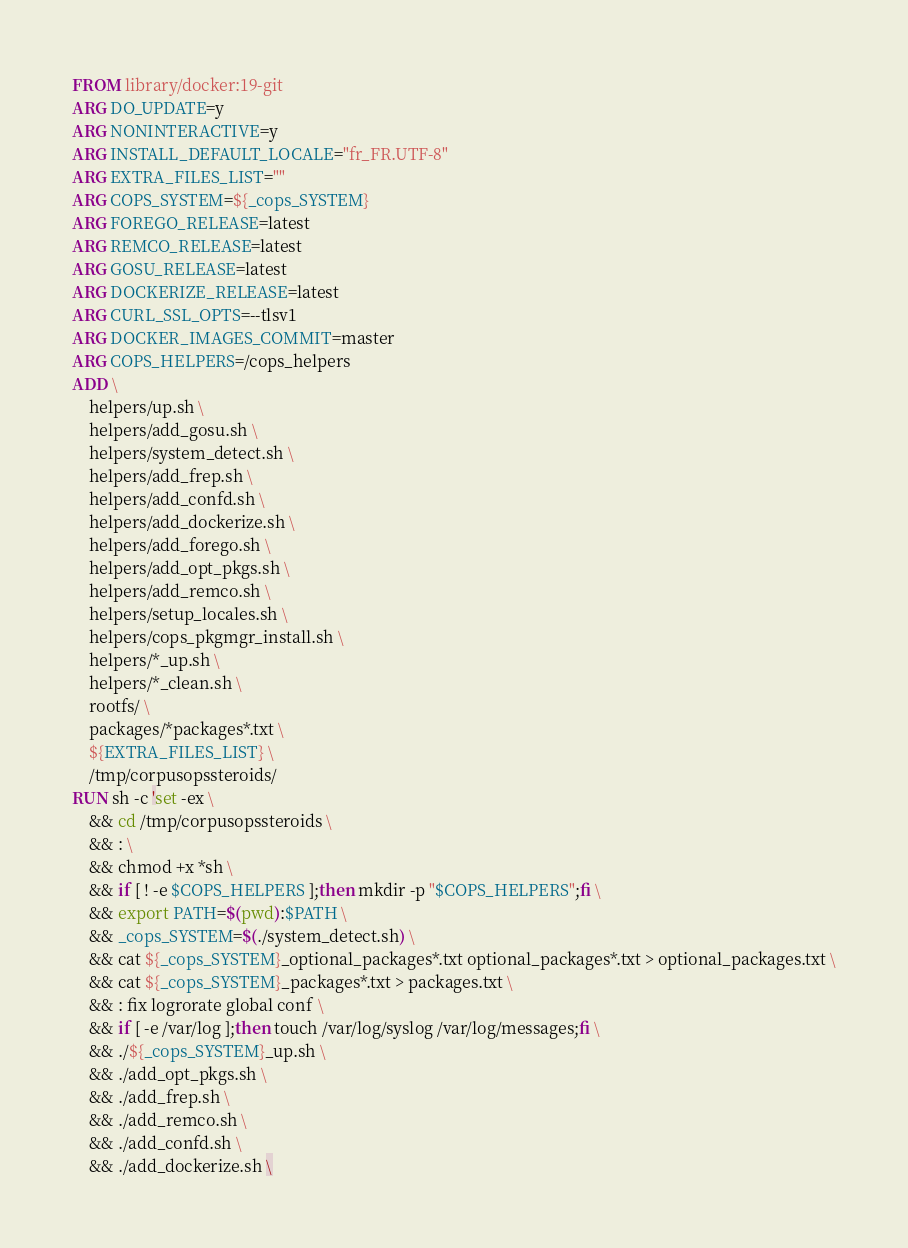<code> <loc_0><loc_0><loc_500><loc_500><_Dockerfile_>FROM library/docker:19-git
ARG DO_UPDATE=y
ARG NONINTERACTIVE=y
ARG INSTALL_DEFAULT_LOCALE="fr_FR.UTF-8"
ARG EXTRA_FILES_LIST=""
ARG COPS_SYSTEM=${_cops_SYSTEM}
ARG FOREGO_RELEASE=latest
ARG REMCO_RELEASE=latest
ARG GOSU_RELEASE=latest
ARG DOCKERIZE_RELEASE=latest
ARG CURL_SSL_OPTS=--tlsv1
ARG DOCKER_IMAGES_COMMIT=master
ARG COPS_HELPERS=/cops_helpers
ADD \
    helpers/up.sh \
    helpers/add_gosu.sh \
    helpers/system_detect.sh \
    helpers/add_frep.sh \
    helpers/add_confd.sh \
    helpers/add_dockerize.sh \
    helpers/add_forego.sh \
    helpers/add_opt_pkgs.sh \
    helpers/add_remco.sh \
    helpers/setup_locales.sh \
    helpers/cops_pkgmgr_install.sh \
    helpers/*_up.sh \
    helpers/*_clean.sh \
    rootfs/ \
    packages/*packages*.txt \
    ${EXTRA_FILES_LIST} \
    /tmp/corpusopssteroids/
RUN sh -c 'set -ex \
    && cd /tmp/corpusopssteroids \
    && : \
    && chmod +x *sh \
    && if [ ! -e $COPS_HELPERS ];then mkdir -p "$COPS_HELPERS";fi \
    && export PATH=$(pwd):$PATH \
    && _cops_SYSTEM=$(./system_detect.sh) \
    && cat ${_cops_SYSTEM}_optional_packages*.txt optional_packages*.txt > optional_packages.txt \
    && cat ${_cops_SYSTEM}_packages*.txt > packages.txt \
    && : fix logrorate global conf \
    && if [ -e /var/log ];then touch /var/log/syslog /var/log/messages;fi \
    && ./${_cops_SYSTEM}_up.sh \
    && ./add_opt_pkgs.sh \
    && ./add_frep.sh \
    && ./add_remco.sh \
    && ./add_confd.sh \
    && ./add_dockerize.sh \</code> 